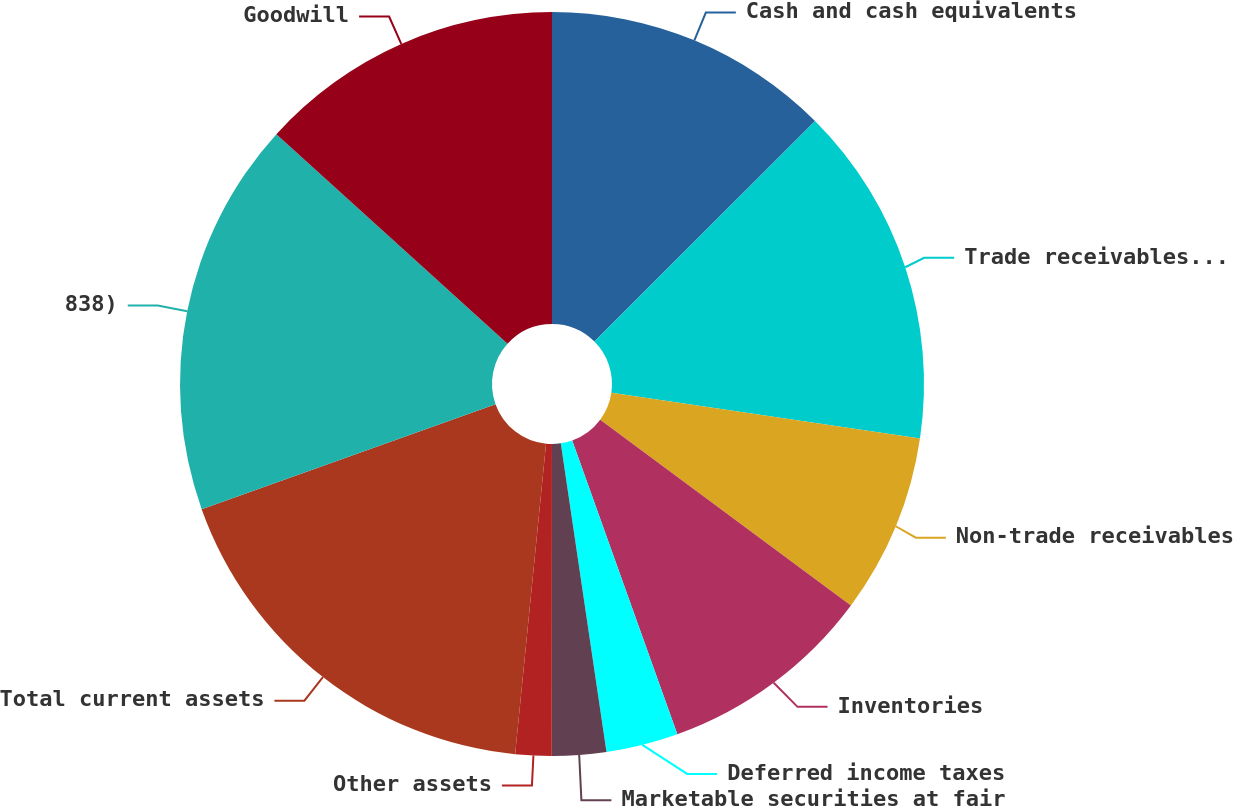Convert chart. <chart><loc_0><loc_0><loc_500><loc_500><pie_chart><fcel>Cash and cash equivalents<fcel>Trade receivables - third<fcel>Non-trade receivables<fcel>Inventories<fcel>Deferred income taxes<fcel>Marketable securities at fair<fcel>Other assets<fcel>Total current assets<fcel>838)<fcel>Goodwill<nl><fcel>12.5%<fcel>14.84%<fcel>7.81%<fcel>9.38%<fcel>3.13%<fcel>2.35%<fcel>1.57%<fcel>17.96%<fcel>17.18%<fcel>13.28%<nl></chart> 